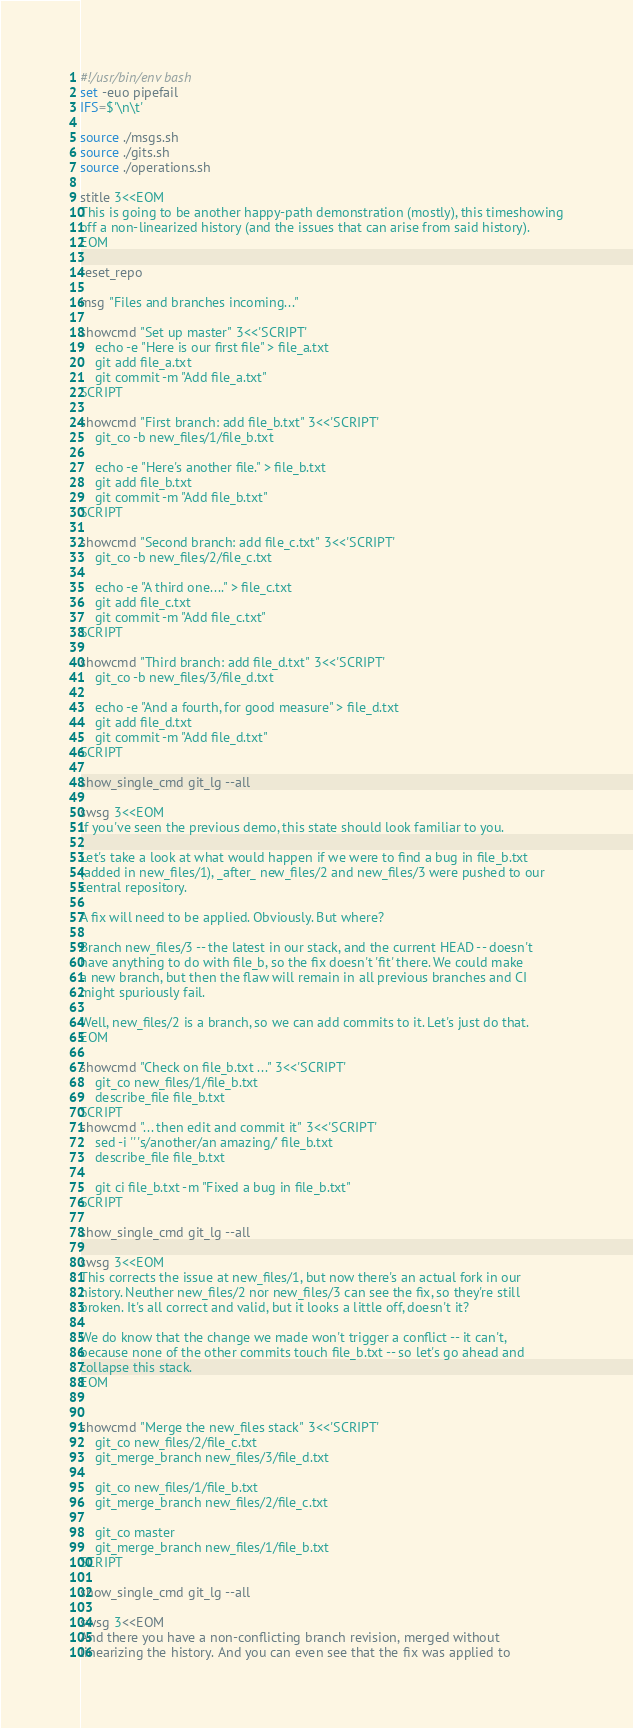<code> <loc_0><loc_0><loc_500><loc_500><_Bash_>#!/usr/bin/env bash
set -euo pipefail
IFS=$'\n\t'

source ./msgs.sh
source ./gits.sh
source ./operations.sh

stitle 3<<EOM
This is going to be another happy-path demonstration (mostly), this timeshowing
off a non-linearized history (and the issues that can arise from said history).
EOM

reset_repo

msg "Files and branches incoming..."

showcmd "Set up master" 3<<'SCRIPT'
    echo -e "Here is our first file" > file_a.txt
    git add file_a.txt
    git commit -m "Add file_a.txt"
SCRIPT

showcmd "First branch: add file_b.txt" 3<<'SCRIPT'
    git_co -b new_files/1/file_b.txt

    echo -e "Here's another file." > file_b.txt
    git add file_b.txt
    git commit -m "Add file_b.txt"
SCRIPT

showcmd "Second branch: add file_c.txt" 3<<'SCRIPT'
    git_co -b new_files/2/file_c.txt

    echo -e "A third one...." > file_c.txt
    git add file_c.txt
    git commit -m "Add file_c.txt"
SCRIPT

showcmd "Third branch: add file_d.txt" 3<<'SCRIPT'
    git_co -b new_files/3/file_d.txt

    echo -e "And a fourth, for good measure" > file_d.txt
    git add file_d.txt
    git commit -m "Add file_d.txt"
SCRIPT

show_single_cmd git_lg --all

swsg 3<<EOM
If you've seen the previous demo, this state should look familiar to you.

Let's take a look at what would happen if we were to find a bug in file_b.txt
(added in new_files/1), _after_ new_files/2 and new_files/3 were pushed to our
central repository.

A fix will need to be applied. Obviously. But where?

Branch new_files/3 -- the latest in our stack, and the current HEAD -- doesn't
have anything to do with file_b, so the fix doesn't 'fit' there. We could make
a new branch, but then the flaw will remain in all previous branches and CI
might spuriously fail.

Well, new_files/2 is a branch, so we can add commits to it. Let's just do that.
EOM

showcmd "Check on file_b.txt ..." 3<<'SCRIPT'
    git_co new_files/1/file_b.txt
    describe_file file_b.txt
SCRIPT
showcmd "... then edit and commit it" 3<<'SCRIPT'
    sed -i '' 's/another/an amazing/' file_b.txt
    describe_file file_b.txt

    git ci file_b.txt -m "Fixed a bug in file_b.txt"
SCRIPT

show_single_cmd git_lg --all

swsg 3<<EOM
This corrects the issue at new_files/1, but now there's an actual fork in our
history. Neuther new_files/2 nor new_files/3 can see the fix, so they're still
broken. It's all correct and valid, but it looks a little off, doesn't it?

We do know that the change we made won't trigger a conflict -- it can't,
because none of the other commits touch file_b.txt -- so let's go ahead and
collapse this stack.
EOM


showcmd "Merge the new_files stack" 3<<'SCRIPT'
    git_co new_files/2/file_c.txt
    git_merge_branch new_files/3/file_d.txt

    git_co new_files/1/file_b.txt
    git_merge_branch new_files/2/file_c.txt

    git_co master
    git_merge_branch new_files/1/file_b.txt
SCRIPT

show_single_cmd git_lg --all

swsg 3<<EOM
And there you have a non-conflicting branch revision, merged without
linearizing the history. And you can even see that the fix was applied to</code> 